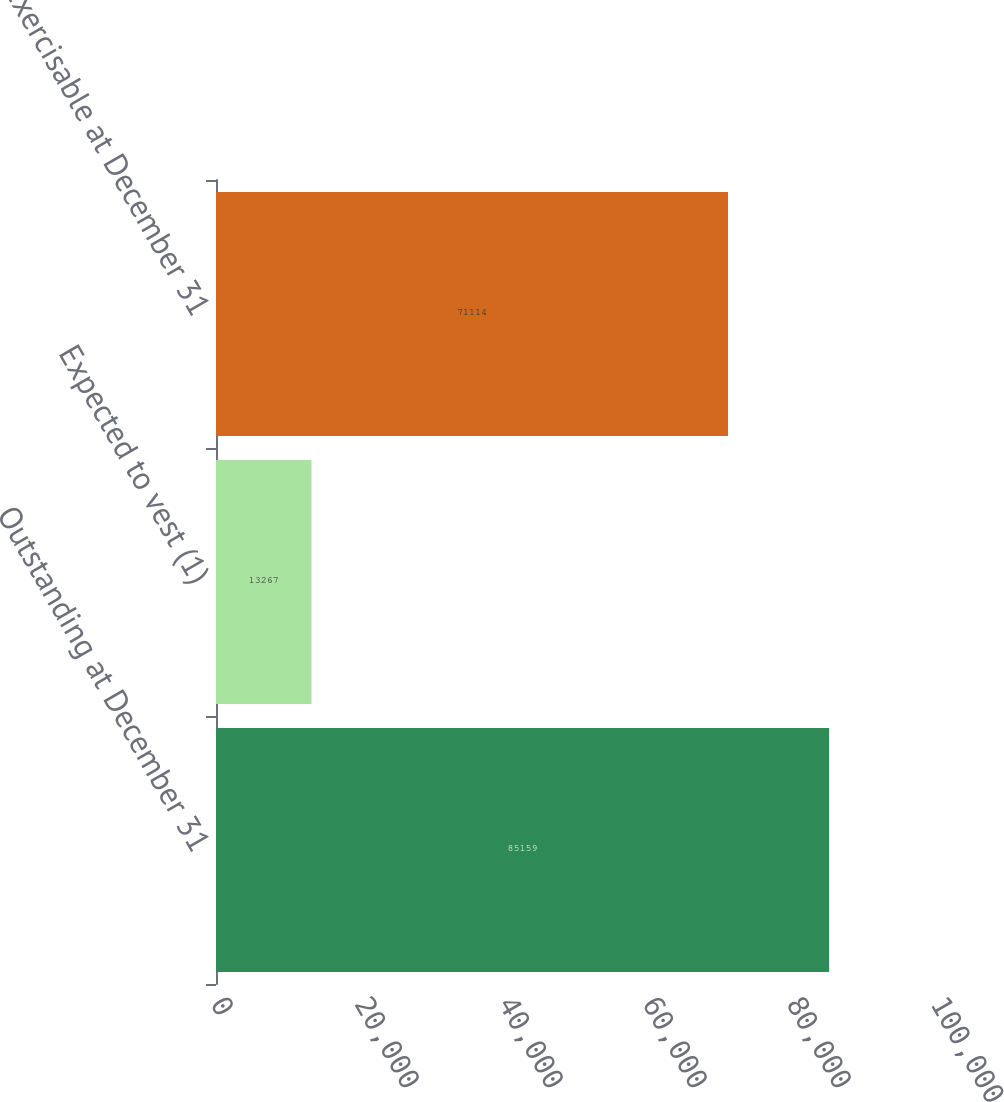<chart> <loc_0><loc_0><loc_500><loc_500><bar_chart><fcel>Outstanding at December 31<fcel>Expected to vest (1)<fcel>Exercisable at December 31<nl><fcel>85159<fcel>13267<fcel>71114<nl></chart> 